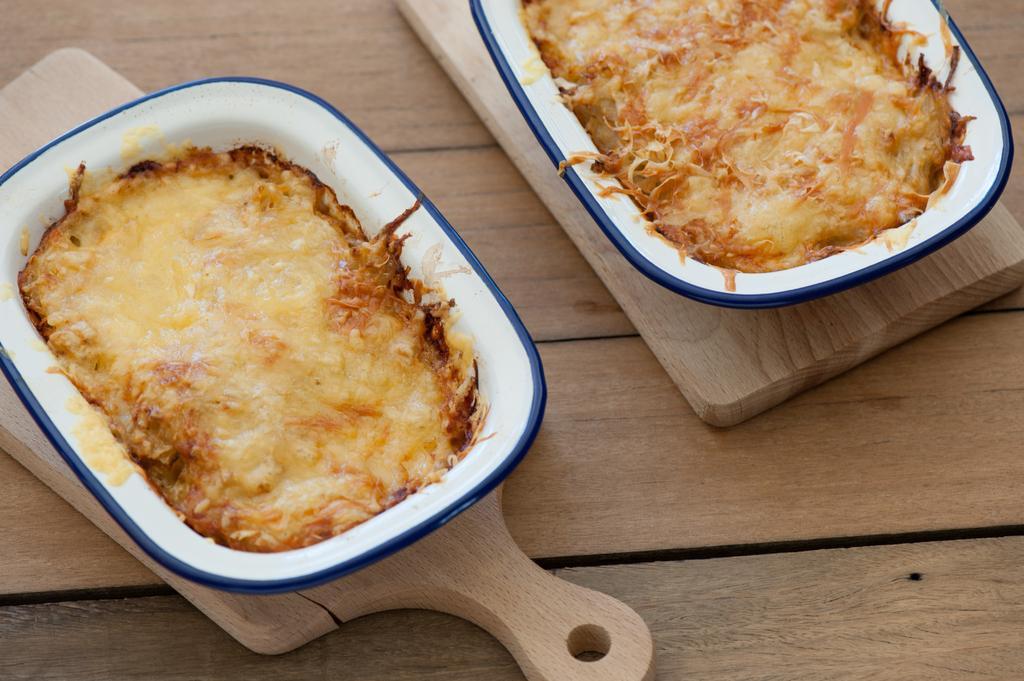Please provide a concise description of this image. In this image we can see food items in bowls on the wooden surface. 